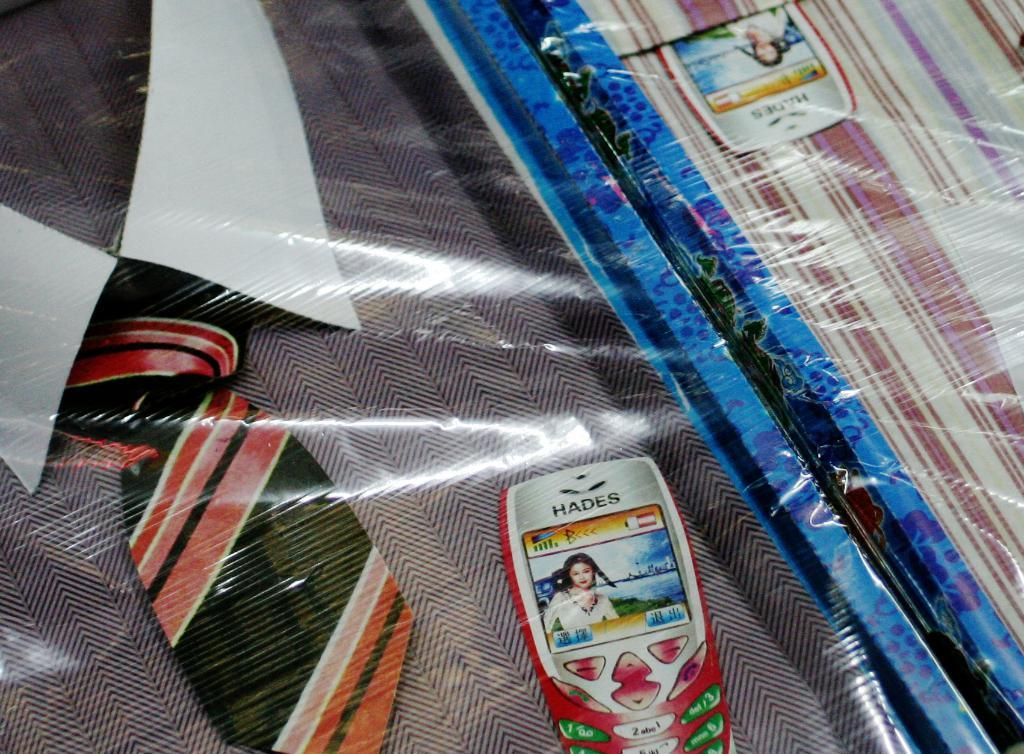What type of clothing item is in the image? There is a t-shirt in the image. What other fabric item is in the image? There is a cloth in the image. How are the t-shirt and cloth being stored or transported? Both the t-shirt and cloth are packed with a cover. Are there any additional decorations or markings on the covers? Yes, there are two stickers on the covers. What type of muscle is visible on the t-shirt in the image? There is no muscle visible on the t-shirt in the image; it is a piece of clothing. What type of print can be seen on the cloth in the image? There is no print visible on the cloth in the image; it is simply described as a fabric item. 